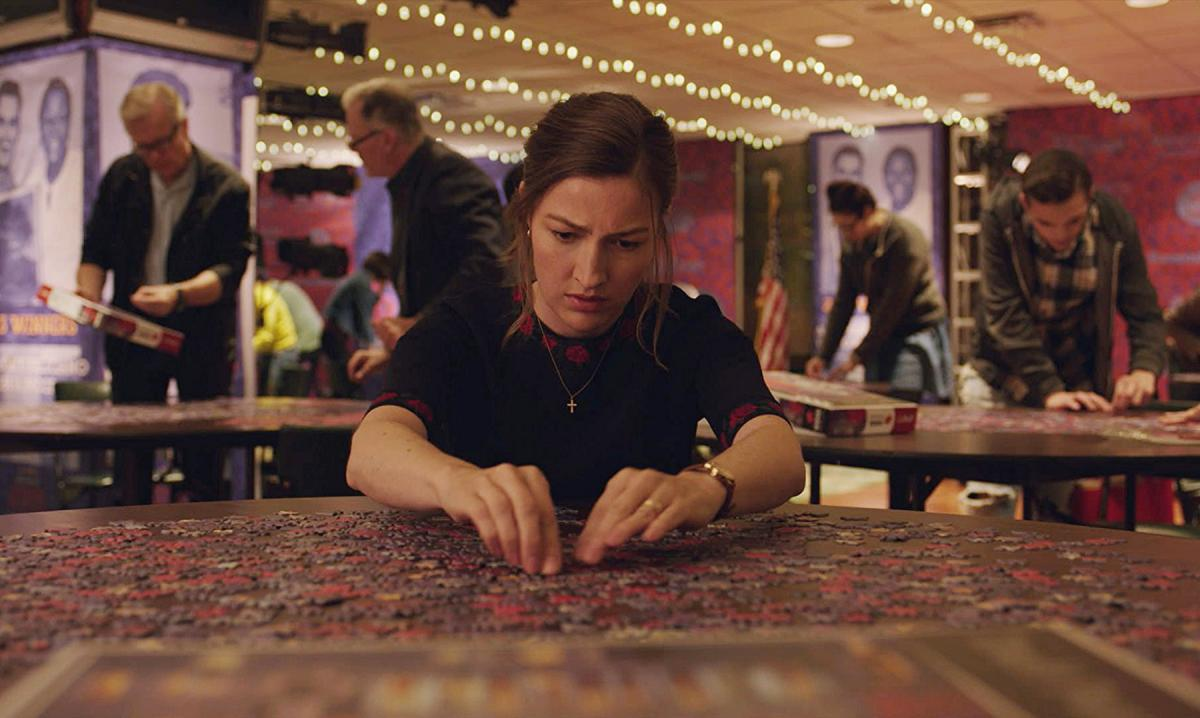What might be the significance of the puzzle she is working on? The puzzle appears to be quite complex and large, perhaps symbolizing a challenge or a metaphor for problem-solving in her life. The action of building a puzzle often relates to patience, attention to detail, and the pursuit of completing a task, which might have personal significance to her. How does her expression contribute to the interpretation of the scene? Her focused expression and intensity signify deep engagement and perhaps a personal connection to the puzzle. This expression might indicate her determination and the pleasure she finds in overcoming challenges, as mirrored in the methodical and mindful process of piece-by-piece puzzle solving. 